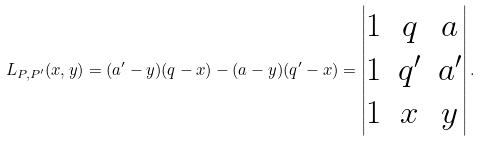<formula> <loc_0><loc_0><loc_500><loc_500>L _ { P , P ^ { \prime } } ( x , y ) = ( a ^ { \prime } - y ) ( q - x ) - ( a - y ) ( q ^ { \prime } - x ) = \left | \begin{matrix} 1 & q & a \\ 1 & q ^ { \prime } & a ^ { \prime } \\ 1 & x & y \end{matrix} \right | .</formula> 